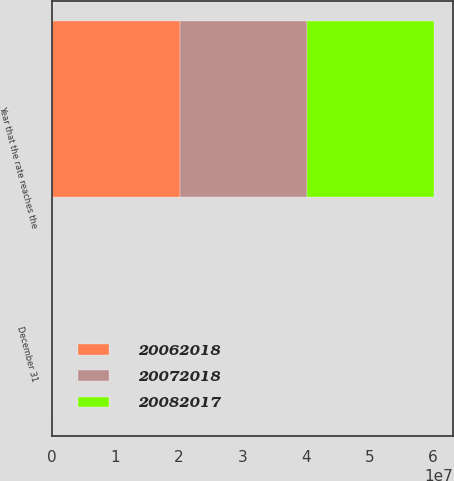Convert chart to OTSL. <chart><loc_0><loc_0><loc_500><loc_500><stacked_bar_chart><ecel><fcel>December 31<fcel>Year that the rate reaches the<nl><fcel>2.0062e+07<fcel>2007<fcel>2.0082e+07<nl><fcel>2.0072e+07<fcel>2006<fcel>2.0072e+07<nl><fcel>2.0082e+07<fcel>2005<fcel>2.0062e+07<nl></chart> 